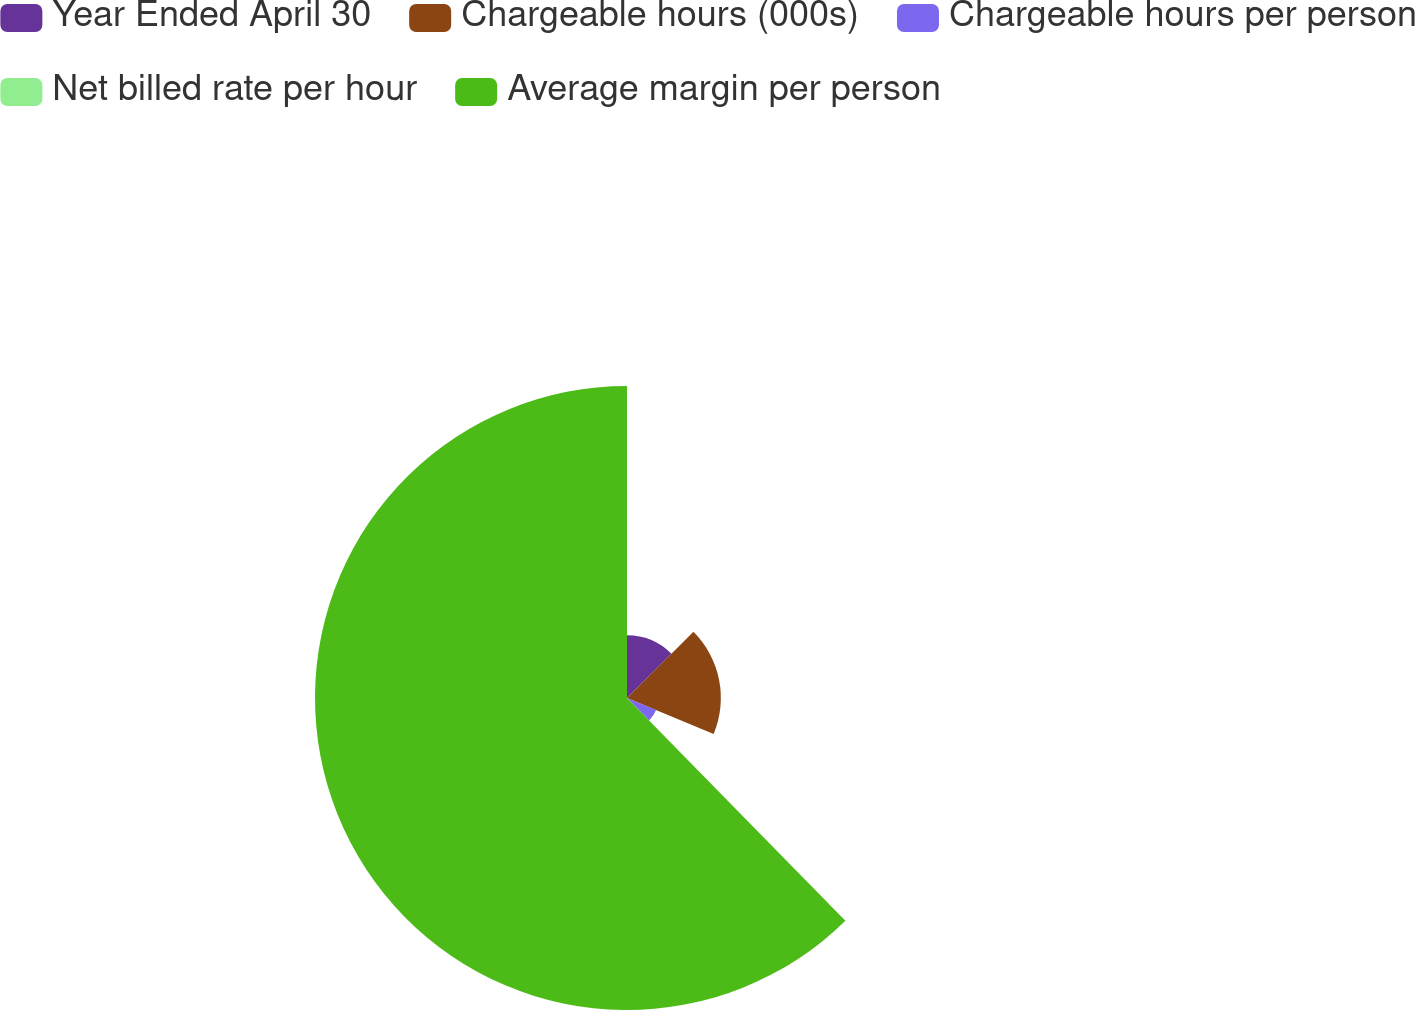Convert chart to OTSL. <chart><loc_0><loc_0><loc_500><loc_500><pie_chart><fcel>Year Ended April 30<fcel>Chargeable hours (000s)<fcel>Chargeable hours per person<fcel>Net billed rate per hour<fcel>Average margin per person<nl><fcel>12.53%<fcel>18.75%<fcel>6.3%<fcel>0.08%<fcel>62.34%<nl></chart> 